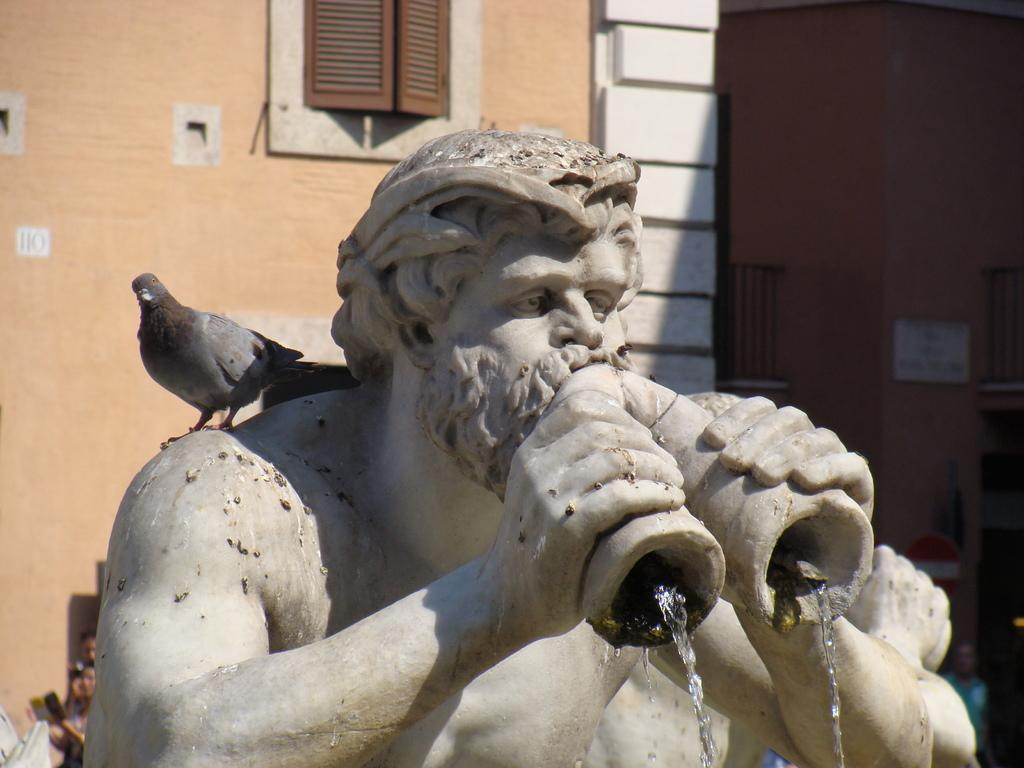What is the main subject of the image? There is a statue in the image. What is the statue doing? Water is coming from the statue. Are there any animals on the statue? Yes, there is a bird on the statue. What can be seen in the background of the image? There is a building with a window in the background of the image. What type of sugar is being used to protest in the image? There is no protest or sugar in the image; it features a statue with water coming from it and a bird on it, with a building and window in the background. 